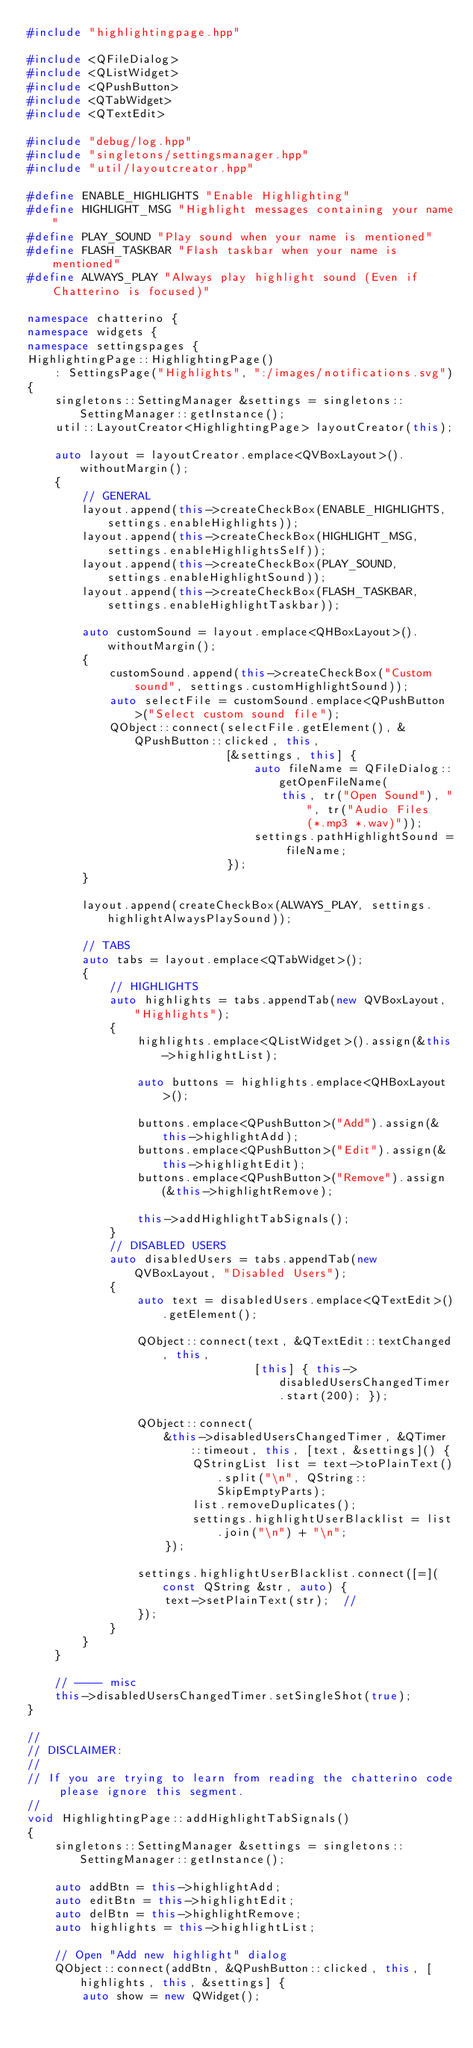<code> <loc_0><loc_0><loc_500><loc_500><_C++_>#include "highlightingpage.hpp"

#include <QFileDialog>
#include <QListWidget>
#include <QPushButton>
#include <QTabWidget>
#include <QTextEdit>

#include "debug/log.hpp"
#include "singletons/settingsmanager.hpp"
#include "util/layoutcreator.hpp"

#define ENABLE_HIGHLIGHTS "Enable Highlighting"
#define HIGHLIGHT_MSG "Highlight messages containing your name"
#define PLAY_SOUND "Play sound when your name is mentioned"
#define FLASH_TASKBAR "Flash taskbar when your name is mentioned"
#define ALWAYS_PLAY "Always play highlight sound (Even if Chatterino is focused)"

namespace chatterino {
namespace widgets {
namespace settingspages {
HighlightingPage::HighlightingPage()
    : SettingsPage("Highlights", ":/images/notifications.svg")
{
    singletons::SettingManager &settings = singletons::SettingManager::getInstance();
    util::LayoutCreator<HighlightingPage> layoutCreator(this);

    auto layout = layoutCreator.emplace<QVBoxLayout>().withoutMargin();
    {
        // GENERAL
        layout.append(this->createCheckBox(ENABLE_HIGHLIGHTS, settings.enableHighlights));
        layout.append(this->createCheckBox(HIGHLIGHT_MSG, settings.enableHighlightsSelf));
        layout.append(this->createCheckBox(PLAY_SOUND, settings.enableHighlightSound));
        layout.append(this->createCheckBox(FLASH_TASKBAR, settings.enableHighlightTaskbar));

        auto customSound = layout.emplace<QHBoxLayout>().withoutMargin();
        {
            customSound.append(this->createCheckBox("Custom sound", settings.customHighlightSound));
            auto selectFile = customSound.emplace<QPushButton>("Select custom sound file");
            QObject::connect(selectFile.getElement(), &QPushButton::clicked, this,
                             [&settings, this] {
                                 auto fileName = QFileDialog::getOpenFileName(
                                     this, tr("Open Sound"), "", tr("Audio Files (*.mp3 *.wav)"));
                                 settings.pathHighlightSound = fileName;
                             });
        }

        layout.append(createCheckBox(ALWAYS_PLAY, settings.highlightAlwaysPlaySound));

        // TABS
        auto tabs = layout.emplace<QTabWidget>();
        {
            // HIGHLIGHTS
            auto highlights = tabs.appendTab(new QVBoxLayout, "Highlights");
            {
                highlights.emplace<QListWidget>().assign(&this->highlightList);

                auto buttons = highlights.emplace<QHBoxLayout>();

                buttons.emplace<QPushButton>("Add").assign(&this->highlightAdd);
                buttons.emplace<QPushButton>("Edit").assign(&this->highlightEdit);
                buttons.emplace<QPushButton>("Remove").assign(&this->highlightRemove);

                this->addHighlightTabSignals();
            }
            // DISABLED USERS
            auto disabledUsers = tabs.appendTab(new QVBoxLayout, "Disabled Users");
            {
                auto text = disabledUsers.emplace<QTextEdit>().getElement();

                QObject::connect(text, &QTextEdit::textChanged, this,
                                 [this] { this->disabledUsersChangedTimer.start(200); });

                QObject::connect(
                    &this->disabledUsersChangedTimer, &QTimer::timeout, this, [text, &settings]() {
                        QStringList list = text->toPlainText().split("\n", QString::SkipEmptyParts);
                        list.removeDuplicates();
                        settings.highlightUserBlacklist = list.join("\n") + "\n";
                    });

                settings.highlightUserBlacklist.connect([=](const QString &str, auto) {
                    text->setPlainText(str);  //
                });
            }
        }
    }

    // ---- misc
    this->disabledUsersChangedTimer.setSingleShot(true);
}

//
// DISCLAIMER:
//
// If you are trying to learn from reading the chatterino code please ignore this segment.
//
void HighlightingPage::addHighlightTabSignals()
{
    singletons::SettingManager &settings = singletons::SettingManager::getInstance();

    auto addBtn = this->highlightAdd;
    auto editBtn = this->highlightEdit;
    auto delBtn = this->highlightRemove;
    auto highlights = this->highlightList;

    // Open "Add new highlight" dialog
    QObject::connect(addBtn, &QPushButton::clicked, this, [highlights, this, &settings] {
        auto show = new QWidget();</code> 